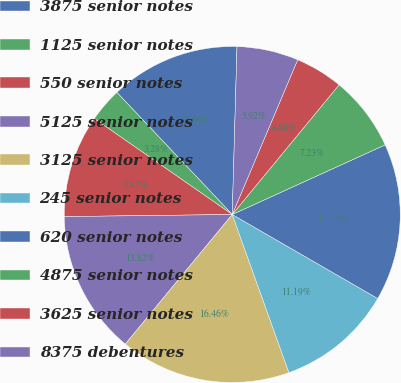<chart> <loc_0><loc_0><loc_500><loc_500><pie_chart><fcel>3875 senior notes<fcel>1125 senior notes<fcel>550 senior notes<fcel>5125 senior notes<fcel>3125 senior notes<fcel>245 senior notes<fcel>620 senior notes<fcel>4875 senior notes<fcel>3625 senior notes<fcel>8375 debentures<nl><fcel>12.5%<fcel>3.28%<fcel>9.87%<fcel>13.82%<fcel>16.46%<fcel>11.19%<fcel>15.14%<fcel>7.23%<fcel>4.6%<fcel>5.92%<nl></chart> 